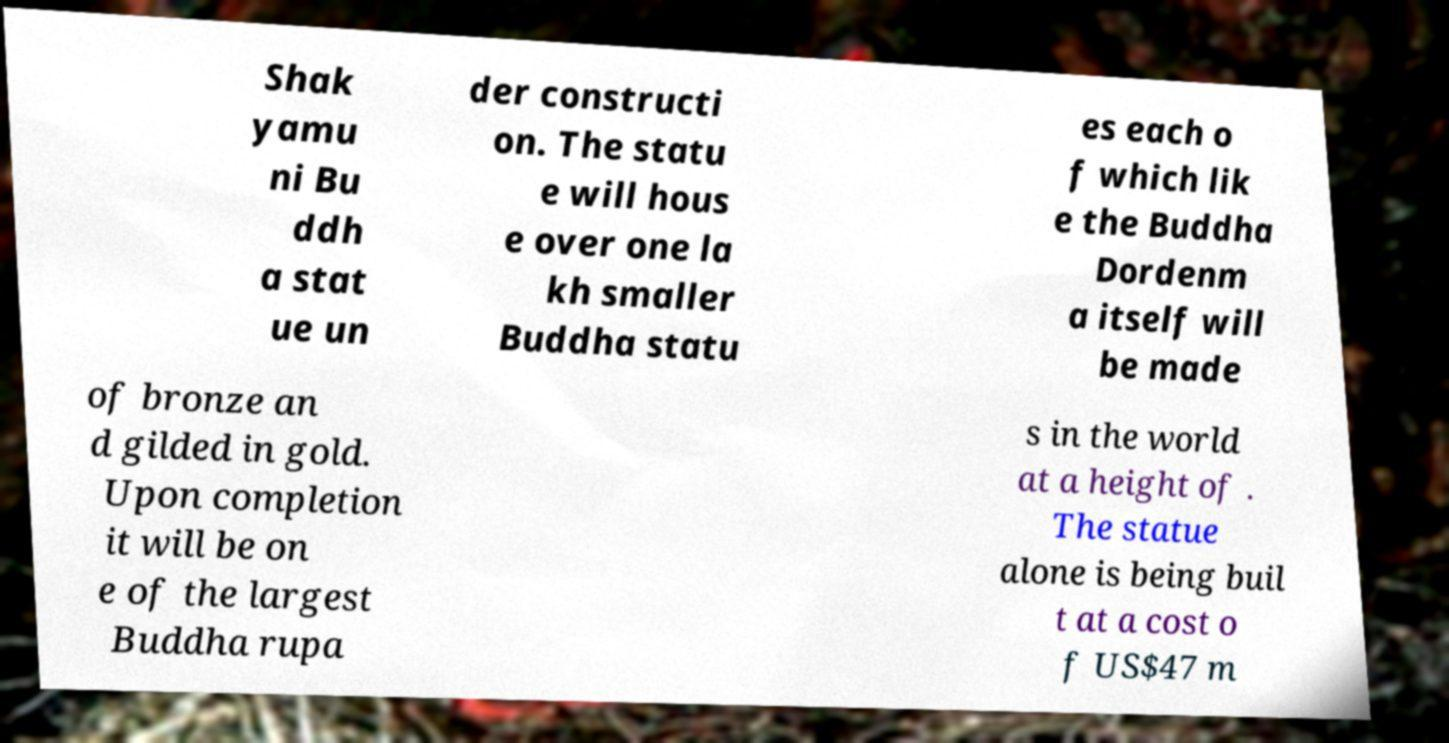Could you assist in decoding the text presented in this image and type it out clearly? Shak yamu ni Bu ddh a stat ue un der constructi on. The statu e will hous e over one la kh smaller Buddha statu es each o f which lik e the Buddha Dordenm a itself will be made of bronze an d gilded in gold. Upon completion it will be on e of the largest Buddha rupa s in the world at a height of . The statue alone is being buil t at a cost o f US$47 m 